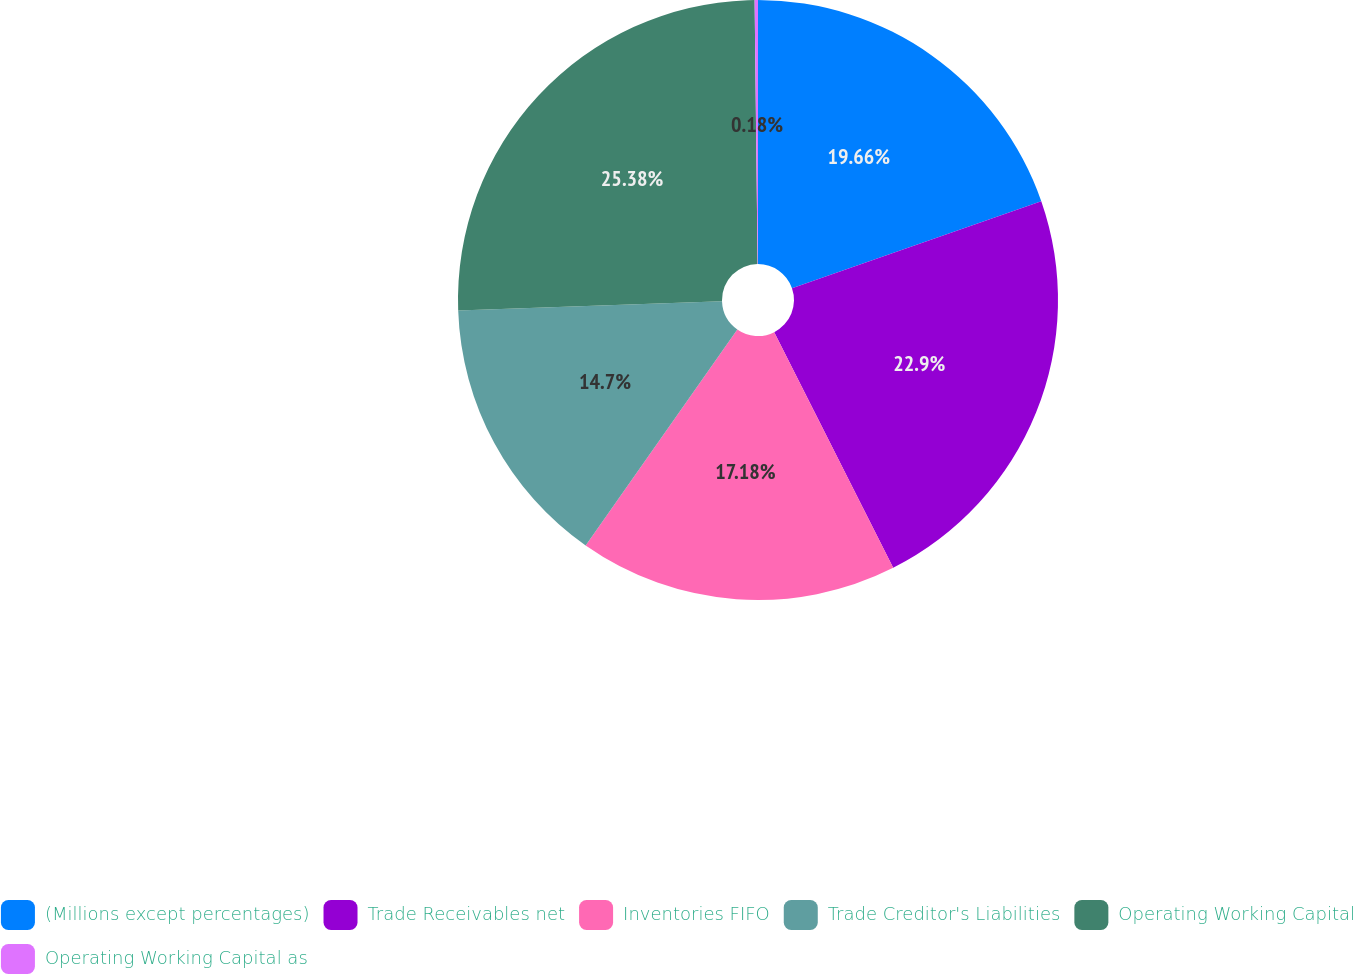<chart> <loc_0><loc_0><loc_500><loc_500><pie_chart><fcel>(Millions except percentages)<fcel>Trade Receivables net<fcel>Inventories FIFO<fcel>Trade Creditor's Liabilities<fcel>Operating Working Capital<fcel>Operating Working Capital as<nl><fcel>19.66%<fcel>22.9%<fcel>17.18%<fcel>14.7%<fcel>25.38%<fcel>0.18%<nl></chart> 